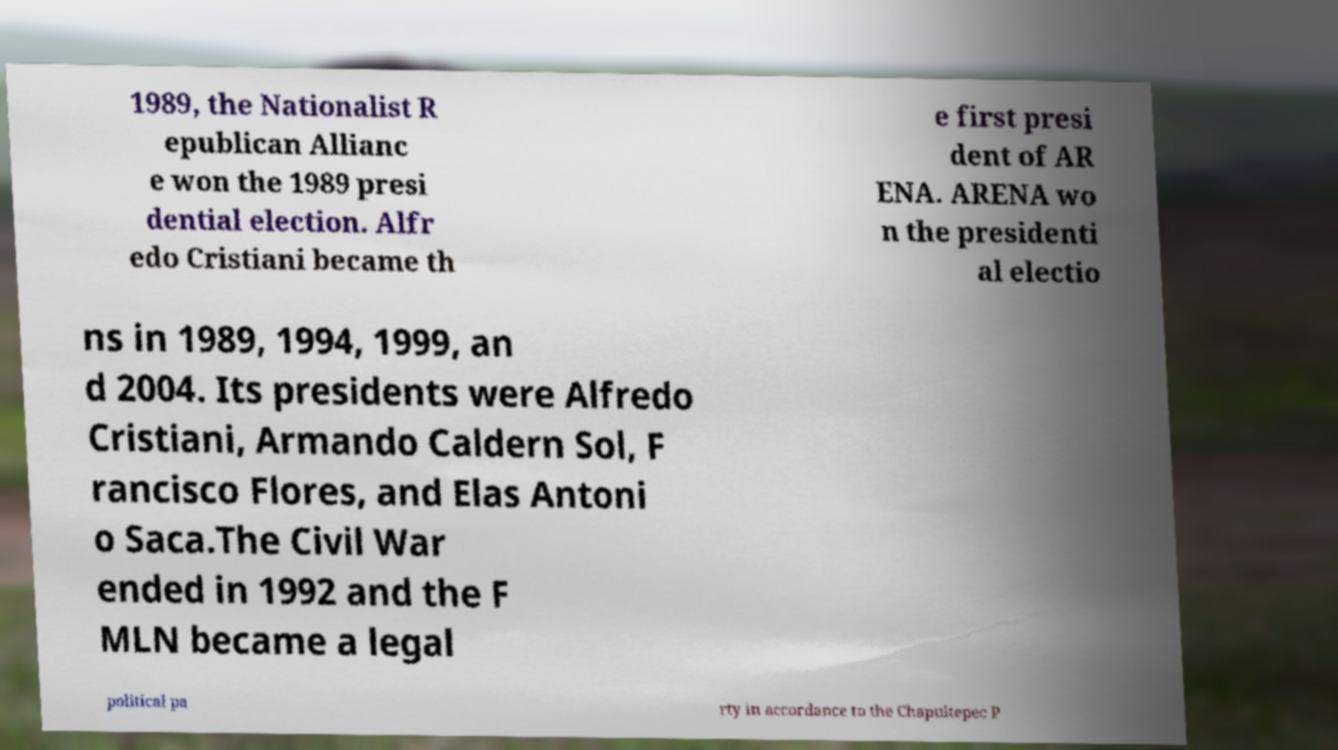Please identify and transcribe the text found in this image. 1989, the Nationalist R epublican Allianc e won the 1989 presi dential election. Alfr edo Cristiani became th e first presi dent of AR ENA. ARENA wo n the presidenti al electio ns in 1989, 1994, 1999, an d 2004. Its presidents were Alfredo Cristiani, Armando Caldern Sol, F rancisco Flores, and Elas Antoni o Saca.The Civil War ended in 1992 and the F MLN became a legal political pa rty in accordance to the Chapultepec P 